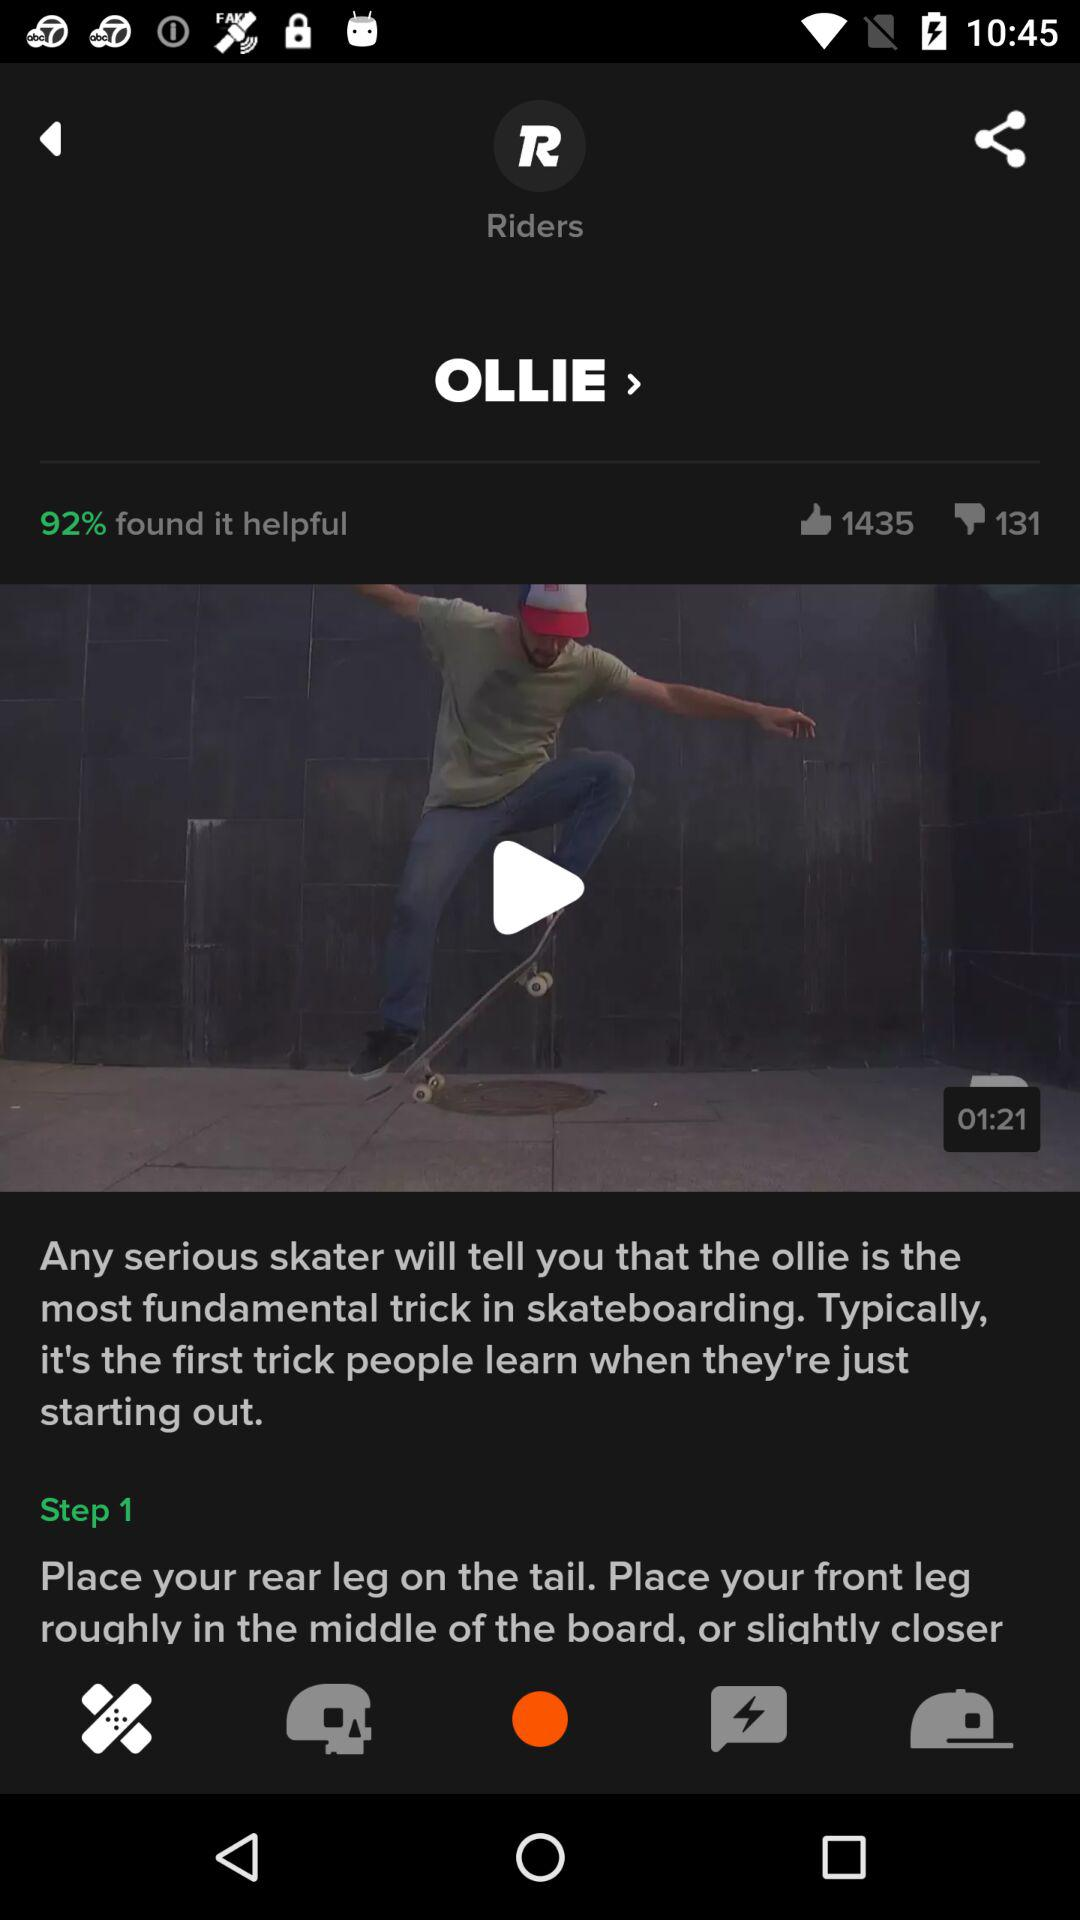What percentage of people found the video helpful? The percentage of people that found the video helpful is 92. 